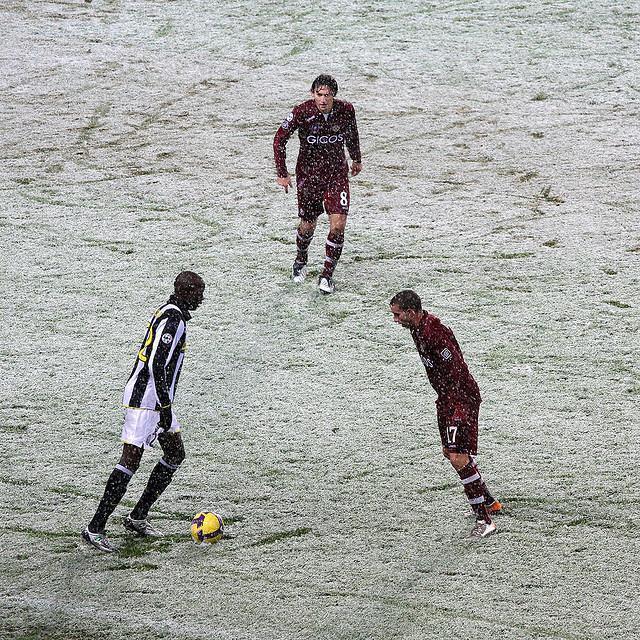What substance is covering the turf?
Answer the question by selecting the correct answer among the 4 following choices.
Options: Salt, sand, ash, snow. Snow. 